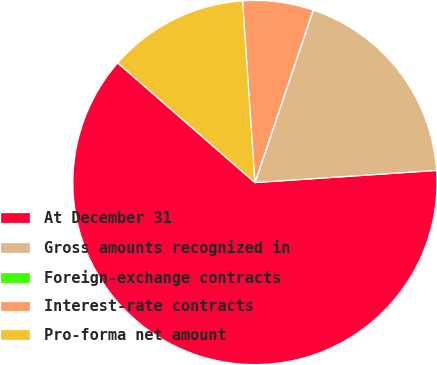<chart> <loc_0><loc_0><loc_500><loc_500><pie_chart><fcel>At December 31<fcel>Gross amounts recognized in<fcel>Foreign-exchange contracts<fcel>Interest-rate contracts<fcel>Pro-forma net amount<nl><fcel>62.47%<fcel>18.75%<fcel>0.01%<fcel>6.26%<fcel>12.5%<nl></chart> 